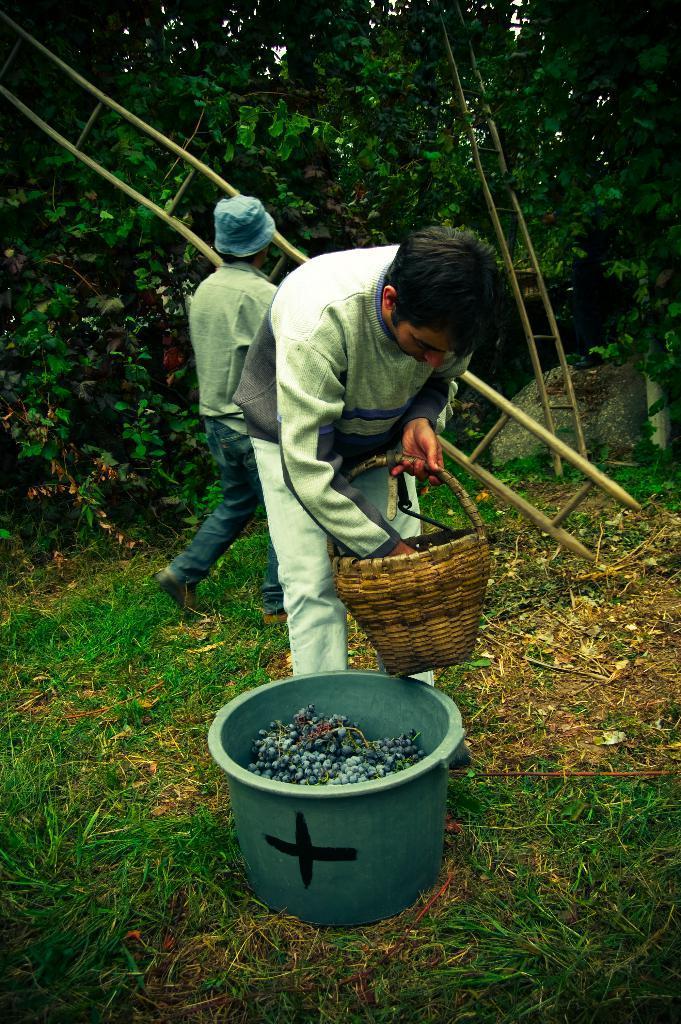How would you summarize this image in a sentence or two? In this picture there is a person standing and holding the basket and there are fruits in the tub. At the back there is a person holding the ladder and he is walking and there are trees. At the bottom there is grass and there are dried leaves. 